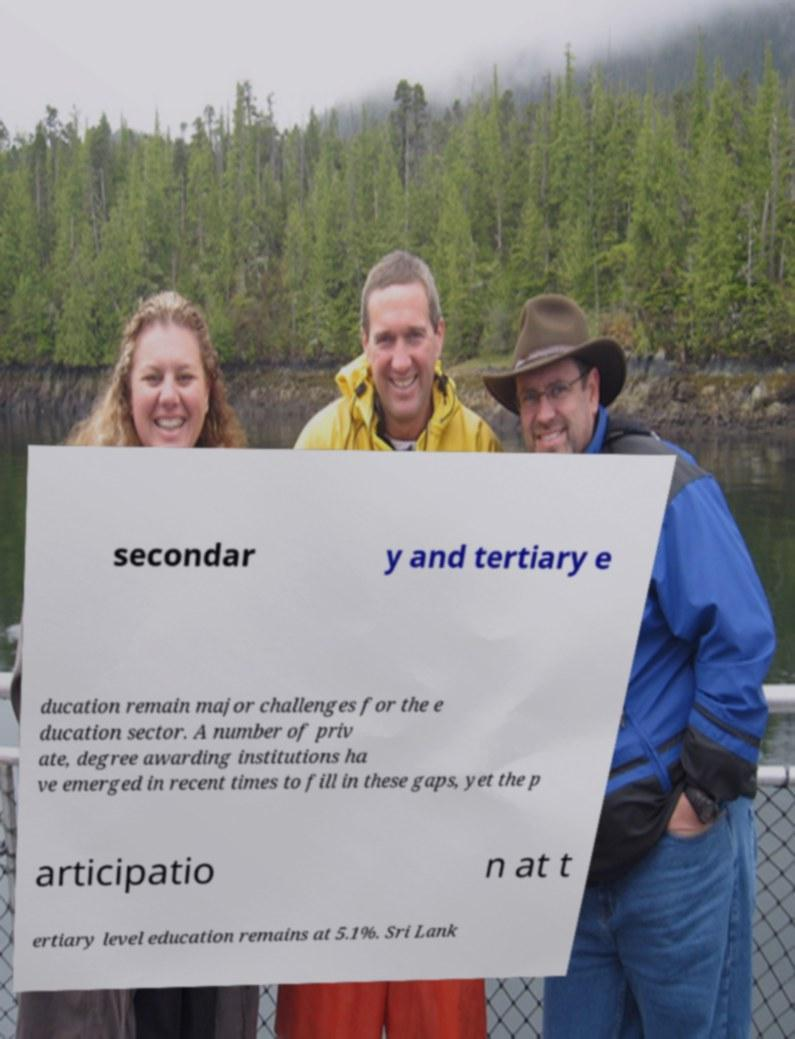Can you read and provide the text displayed in the image?This photo seems to have some interesting text. Can you extract and type it out for me? secondar y and tertiary e ducation remain major challenges for the e ducation sector. A number of priv ate, degree awarding institutions ha ve emerged in recent times to fill in these gaps, yet the p articipatio n at t ertiary level education remains at 5.1%. Sri Lank 